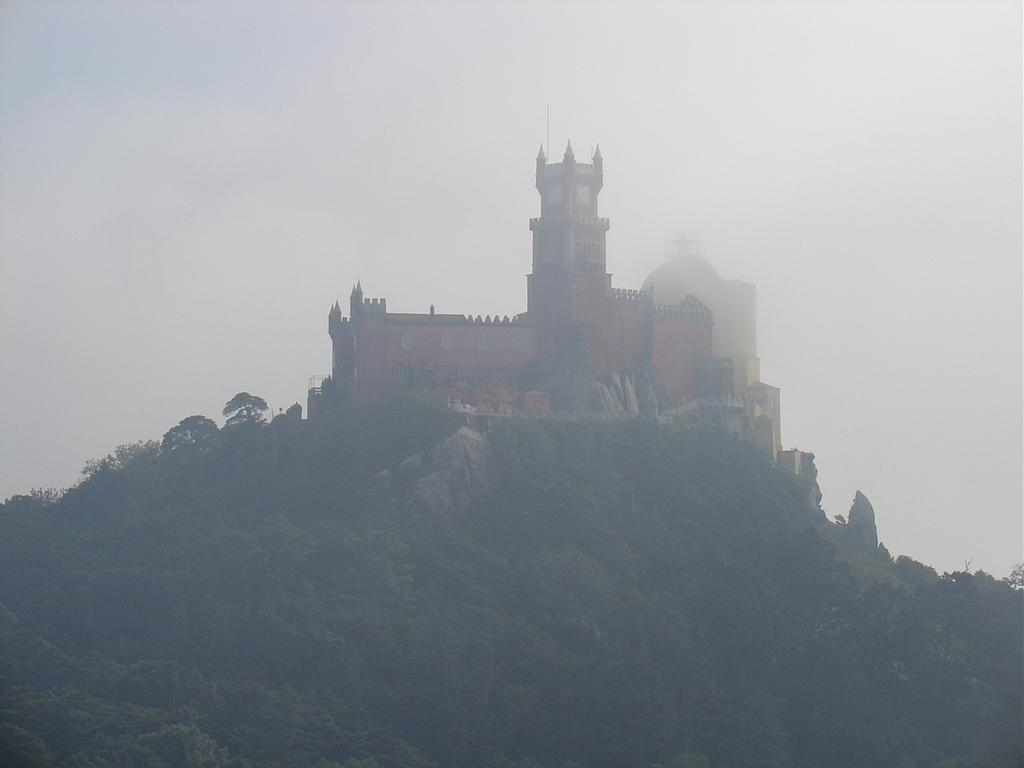What is the main structure in the center of the image? There is a building in the center of the image. What can be seen at the bottom of the image? There are mountains and trees at the bottom of the image. What is visible at the top of the image? The sky is visible at the top of the image. What arithmetic problem is being solved on the side of the building in the image? There is no arithmetic problem visible on the side of the building in the image. 